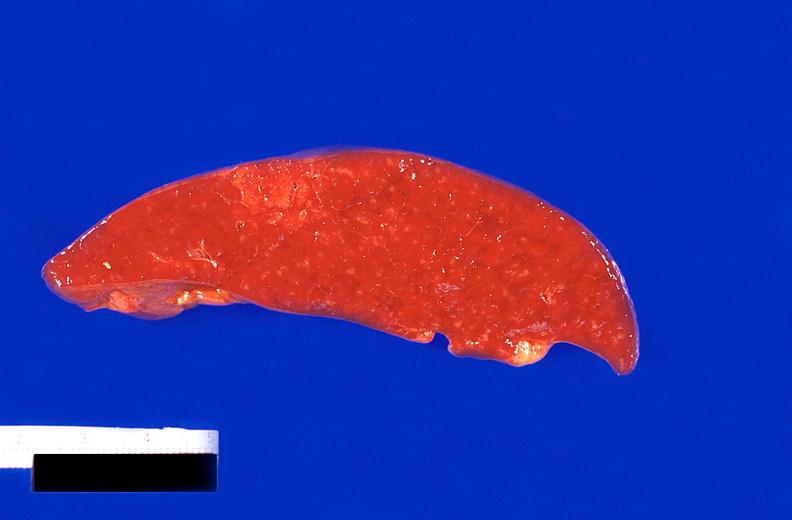what does this image show?
Answer the question using a single word or phrase. Spleen 